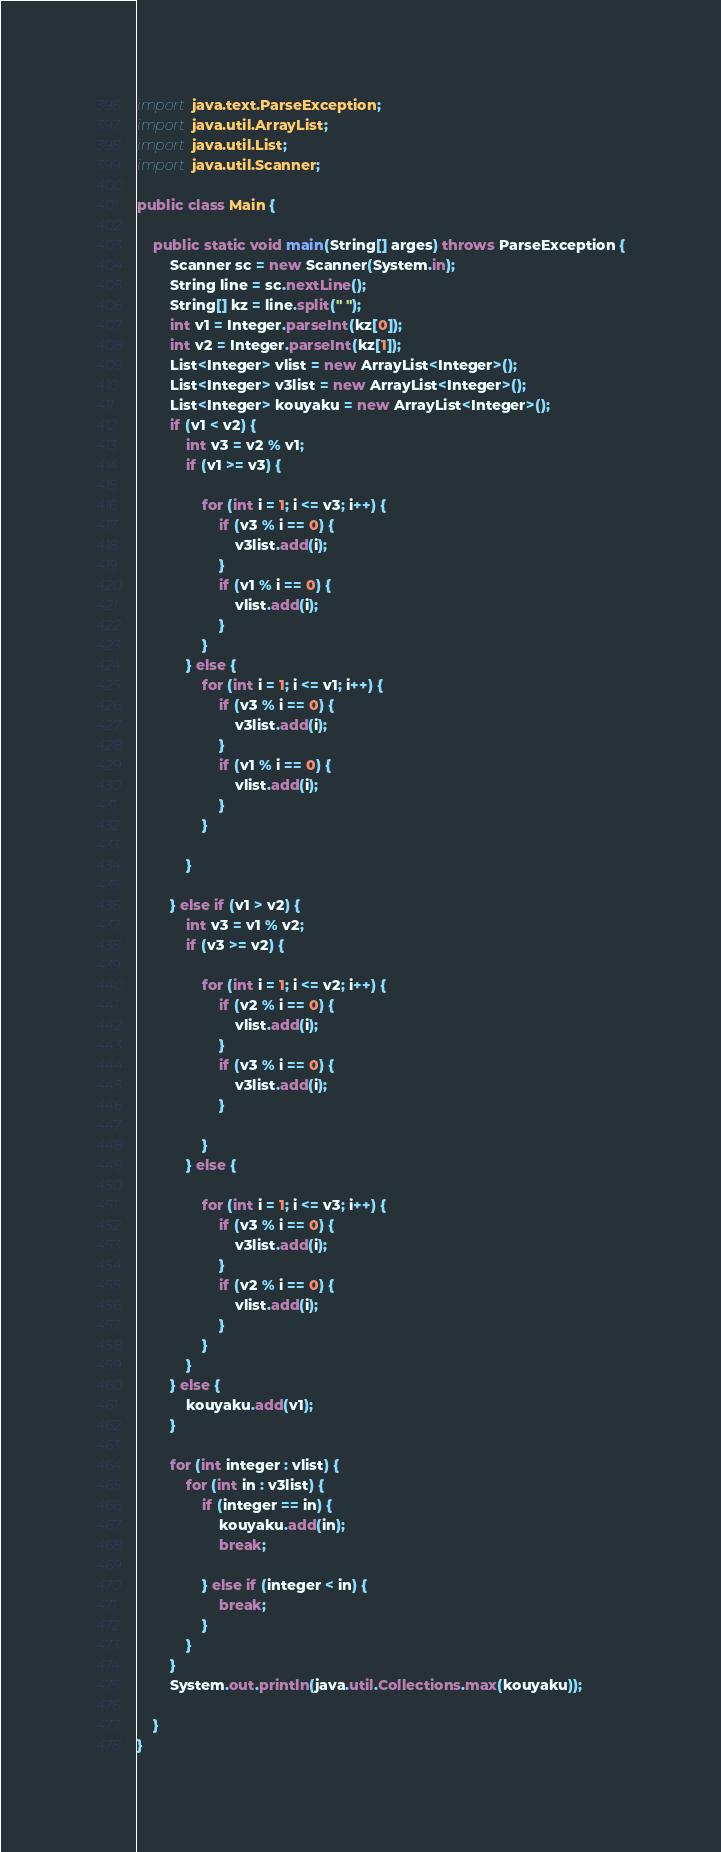<code> <loc_0><loc_0><loc_500><loc_500><_Java_>import java.text.ParseException;
import java.util.ArrayList;
import java.util.List;
import java.util.Scanner;

public class Main {

	public static void main(String[] arges) throws ParseException {
		Scanner sc = new Scanner(System.in);
		String line = sc.nextLine();
		String[] kz = line.split(" ");
		int v1 = Integer.parseInt(kz[0]);
		int v2 = Integer.parseInt(kz[1]);
		List<Integer> vlist = new ArrayList<Integer>();
		List<Integer> v3list = new ArrayList<Integer>();
		List<Integer> kouyaku = new ArrayList<Integer>();
		if (v1 < v2) {
			int v3 = v2 % v1;
			if (v1 >= v3) {

				for (int i = 1; i <= v3; i++) {
					if (v3 % i == 0) {
						v3list.add(i);
					}
					if (v1 % i == 0) {
						vlist.add(i);
					}
				}
			} else {
				for (int i = 1; i <= v1; i++) {
					if (v3 % i == 0) {
						v3list.add(i);
					}
					if (v1 % i == 0) {
						vlist.add(i);
					}
				}

			}

		} else if (v1 > v2) {
			int v3 = v1 % v2;
			if (v3 >= v2) {

				for (int i = 1; i <= v2; i++) {
					if (v2 % i == 0) {
						vlist.add(i);
					}
					if (v3 % i == 0) {
						v3list.add(i);
					}

				}
			} else {

				for (int i = 1; i <= v3; i++) {
					if (v3 % i == 0) {
						v3list.add(i);
					}
					if (v2 % i == 0) {
						vlist.add(i);
					}
				}
			}
		} else {
			kouyaku.add(v1);
		}

		for (int integer : vlist) {
			for (int in : v3list) {
				if (integer == in) {
					kouyaku.add(in);
					break;

				} else if (integer < in) {
					break;
				}
			}
		}
		System.out.println(java.util.Collections.max(kouyaku));

	}
}</code> 